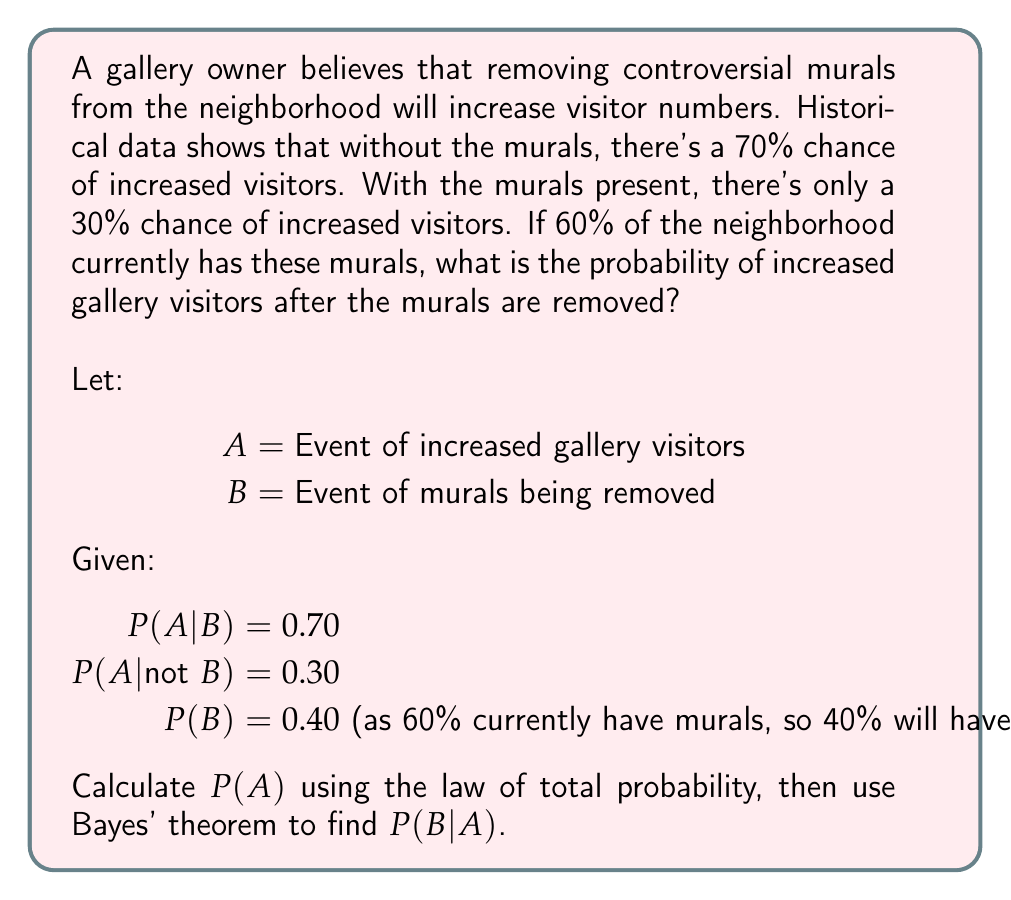Can you answer this question? To solve this problem, we'll use the law of total probability and Bayes' theorem.

Step 1: Calculate P(A) using the law of total probability
$$P(A) = P(A|B) \cdot P(B) + P(A|\text{not } B) \cdot P(\text{not } B)$$
$$P(A) = 0.70 \cdot 0.40 + 0.30 \cdot 0.60$$
$$P(A) = 0.28 + 0.18 = 0.46$$

Step 2: Use Bayes' theorem to calculate P(B|A)
$$P(B|A) = \frac{P(A|B) \cdot P(B)}{P(A)}$$

Step 3: Substitute the known values
$$P(B|A) = \frac{0.70 \cdot 0.40}{0.46}$$

Step 4: Calculate the final result
$$P(B|A) = \frac{0.28}{0.46} \approx 0.6087$$

Therefore, the probability of increased gallery visitors after the murals are removed is approximately 0.6087 or 60.87%.
Answer: 0.6087 (or 60.87%) 